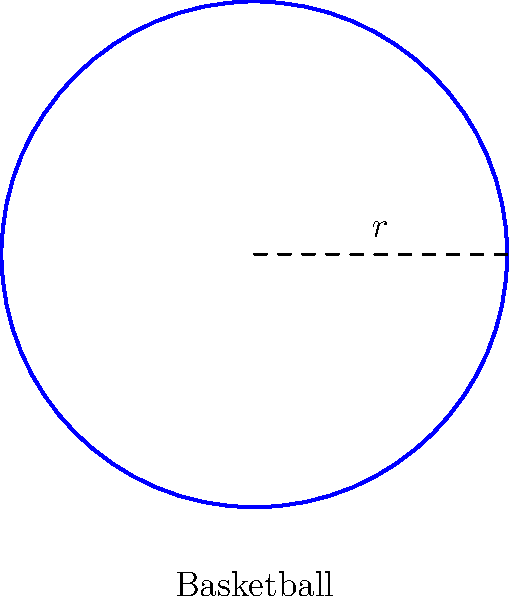As a basketball coach, you're teaching your players about the properties of the ball. If a regulation basketball has a diameter of 24 cm, what is its surface area? Round your answer to the nearest square centimeter. Let's approach this step-by-step:

1) First, recall the formula for the surface area of a sphere:
   $$A = 4\pi r^2$$
   where $A$ is the surface area and $r$ is the radius.

2) We're given the diameter, which is 24 cm. The radius is half of this:
   $$r = \frac{24}{2} = 12 \text{ cm}$$

3) Now, let's substitute this into our formula:
   $$A = 4\pi (12\text{ cm})^2$$

4) Simplify:
   $$A = 4\pi (144\text{ cm}^2) = 576\pi \text{ cm}^2$$

5) Now, let's calculate this:
   $$A \approx 1,809.56 \text{ cm}^2$$

6) Rounding to the nearest square centimeter:
   $$A \approx 1,810 \text{ cm}^2$$
Answer: 1,810 cm² 